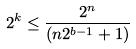<formula> <loc_0><loc_0><loc_500><loc_500>2 ^ { k } \leq \frac { 2 ^ { n } } { ( n 2 ^ { b - 1 } + 1 ) }</formula> 